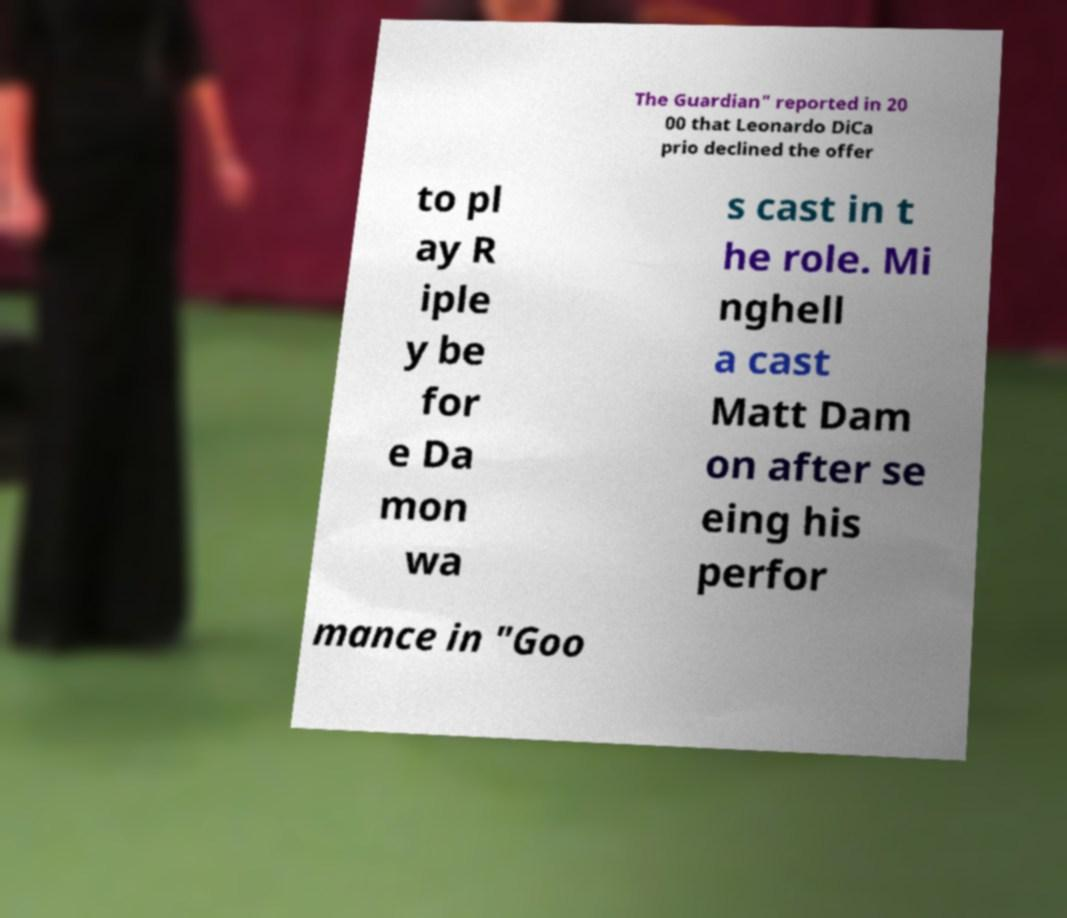Please read and relay the text visible in this image. What does it say? The Guardian" reported in 20 00 that Leonardo DiCa prio declined the offer to pl ay R iple y be for e Da mon wa s cast in t he role. Mi nghell a cast Matt Dam on after se eing his perfor mance in "Goo 